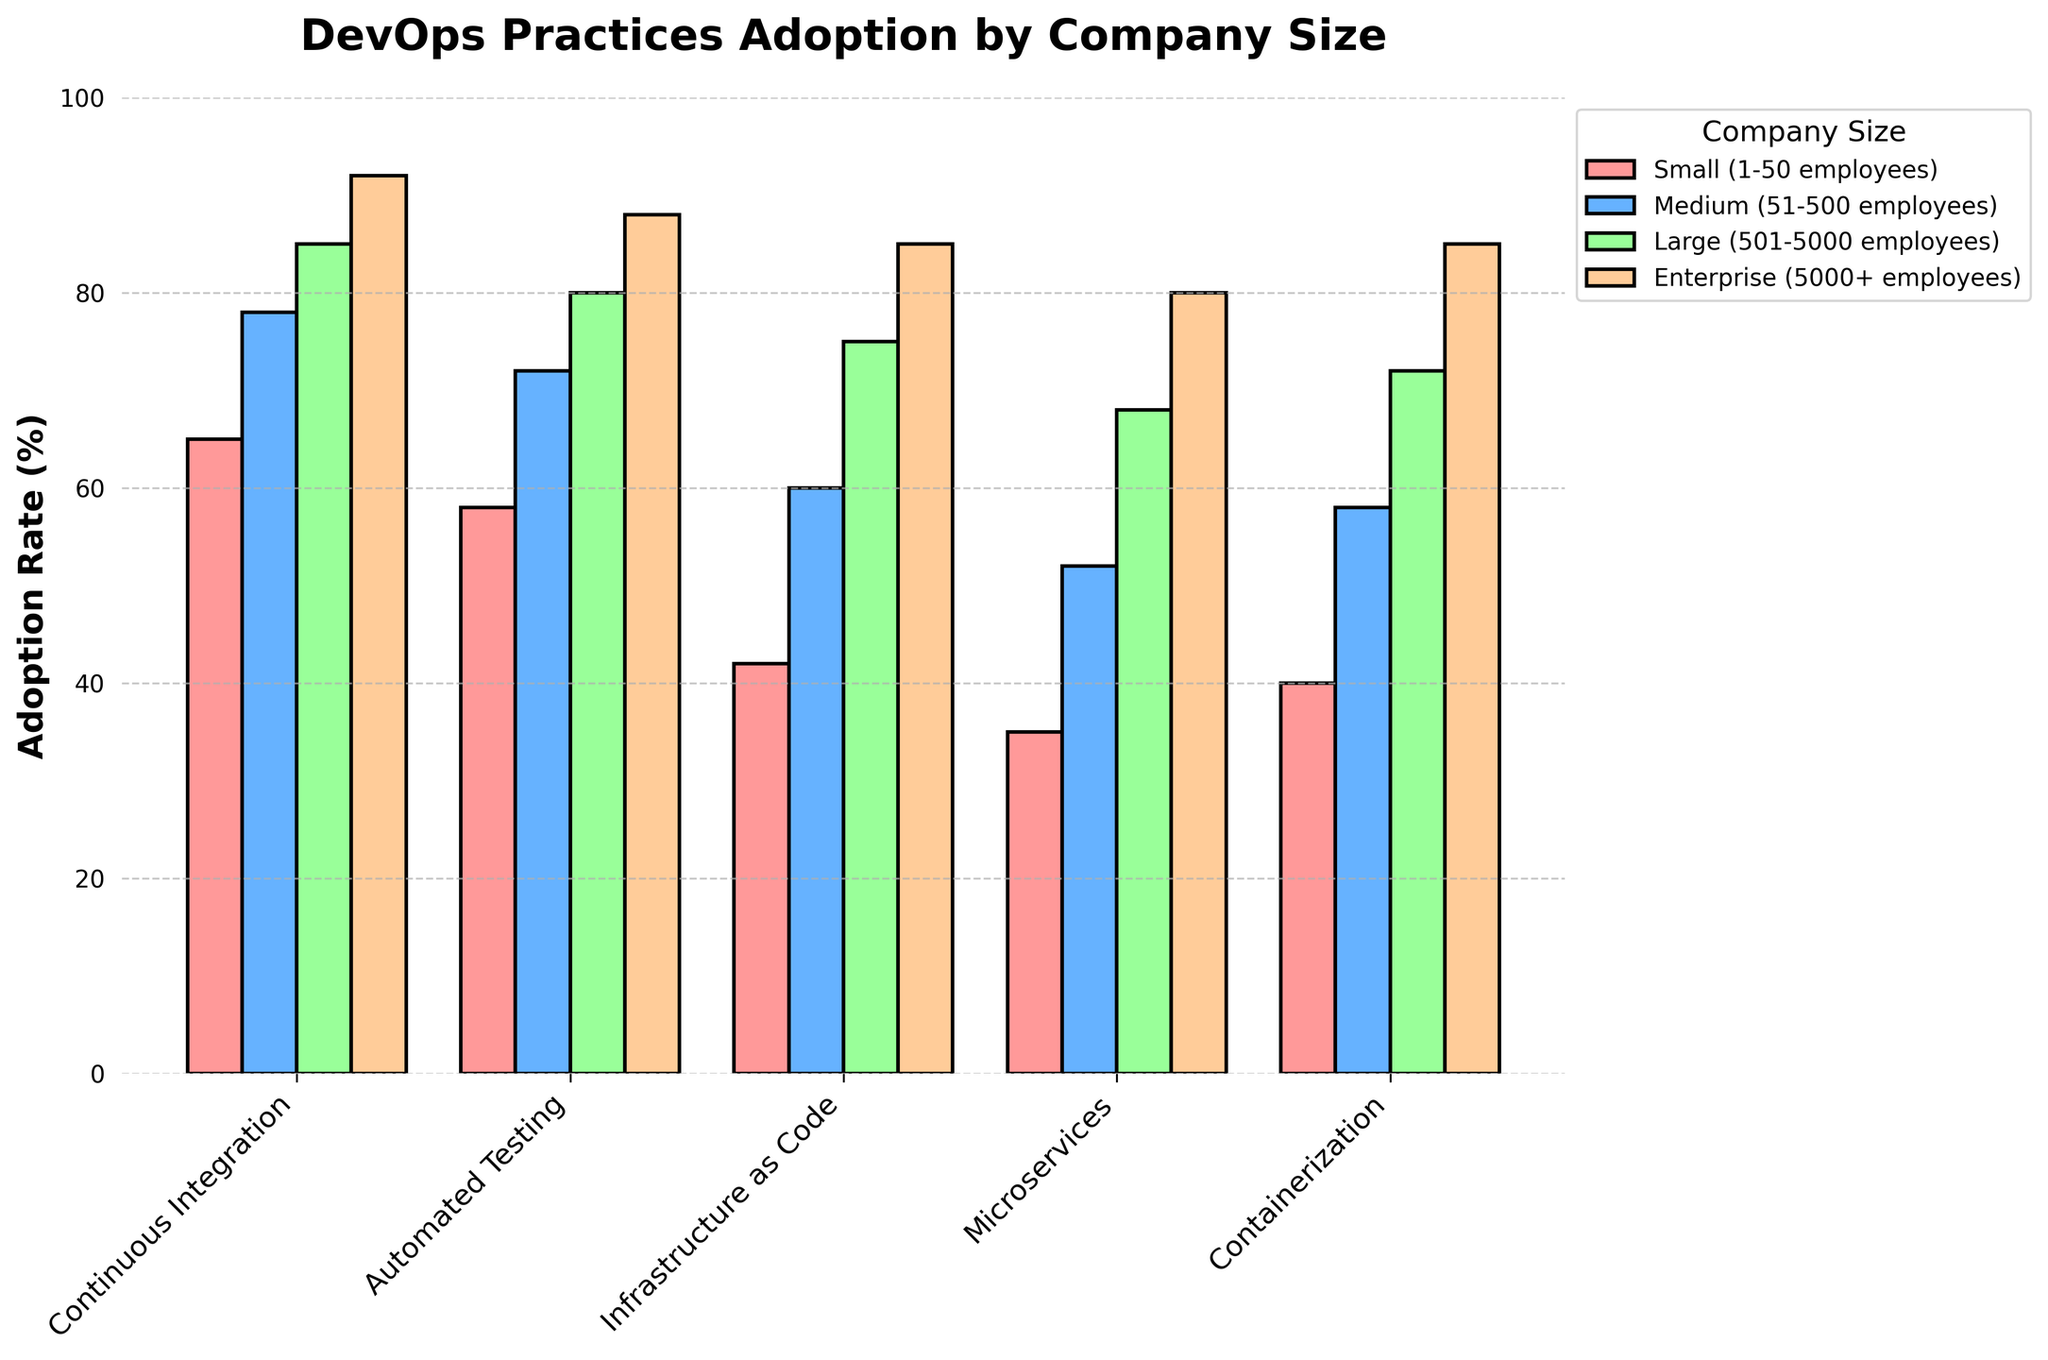Which company size has the highest adoption rate for Continuous Integration? By examining the bar representing Continuous Integration across all company sizes, the highest bar belongs to Enterprise (5000+ employees) with a 92% adoption rate.
Answer: Enterprise (5000+ employees) How much greater is the adoption rate of Microservices for Large companies compared to Small companies? The adoption rate for Microservices in Large companies is 68%, while for Small companies, it is 35%. The difference is 68% - 35% = 33%.
Answer: 33% What is the average adoption rate of Infrastructure as Code across all company sizes? The adoption rates for Infrastructure as Code are 42%, 60%, 75%, and 85% for Small, Medium, Large, and Enterprise companies respectively. The sum of these values is 42% + 60% + 75% + 85% = 262%. The average is 262% / 4 = 65.5%.
Answer: 65.5% What is the lowest adoption rate across all DevOps practices by Medium companies? By looking at all the percentages for Medium companies, the lowest adoption rate is for Infrastructure as Code at 60%.
Answer: 60% Which company size has the smallest gap between the adoption rates of Automated Testing and Containerization? For Small companies, the gap is 58% - 40% = 18%. For Medium companies, it is 72% - 58% = 14%. For Large companies, it’s 80% - 72% = 8%. For Enterprise companies, it’s 88% - 85% = 3%. The smallest gap is for Enterprise companies.
Answer: Enterprise (5000+ employees) What color is used to represent Small companies in the chart? The bar color for Small companies can be identified visually by looking at the legend. It is represented in red.
Answer: Red In which DevOps practice do Medium-sized companies have nearly double the adoption rate compared to Small companies? Checking each practice, for Infrastructure as Code, Medium companies have a 60% adoption rate compared to 42% for Small companies. This is not nearly double. For Automated Testing, it's 72% vs 58%, which is also not double. For Containerization, it's 58% vs 40%, which isn't double. But for Microservices, Medium companies have 52% compared to Small companies at 35%, which is close to double.
Answer: Microservices Among Small, Medium, Large, and Enterprise companies, which one shows equal adoption rates for any two DevOps practices? Looking at each company size, Small, Medium, and Large don’t show equal adoption rates among different practices. However, the Enterprise companies show equal adoption rates for Containerization and Automated Testing, both at 85%.
Answer: Enterprise (5000+ employees) What is the total adoption rate for all practices combined by Large companies? Summing up the adoption rates for all practices by Large companies: Continuous Integration (85%), Automated Testing (80%), Infrastructure as Code (75%), Microservices (68%), and Containerization (72%). The total is 85% + 80% + 75% + 68% + 72% = 380%.
Answer: 380% 